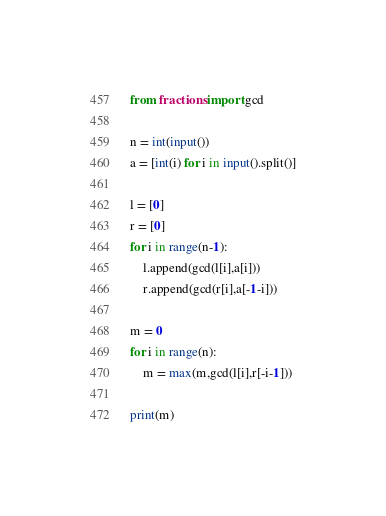<code> <loc_0><loc_0><loc_500><loc_500><_Python_>from fractions import gcd

n = int(input())
a = [int(i) for i in input().split()]

l = [0]
r = [0]
for i in range(n-1):
    l.append(gcd(l[i],a[i]))
    r.append(gcd(r[i],a[-1-i]))

m = 0
for i in range(n):
    m = max(m,gcd(l[i],r[-i-1]))

print(m)</code> 